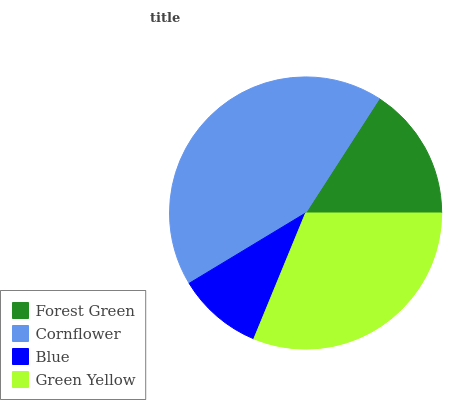Is Blue the minimum?
Answer yes or no. Yes. Is Cornflower the maximum?
Answer yes or no. Yes. Is Cornflower the minimum?
Answer yes or no. No. Is Blue the maximum?
Answer yes or no. No. Is Cornflower greater than Blue?
Answer yes or no. Yes. Is Blue less than Cornflower?
Answer yes or no. Yes. Is Blue greater than Cornflower?
Answer yes or no. No. Is Cornflower less than Blue?
Answer yes or no. No. Is Green Yellow the high median?
Answer yes or no. Yes. Is Forest Green the low median?
Answer yes or no. Yes. Is Blue the high median?
Answer yes or no. No. Is Cornflower the low median?
Answer yes or no. No. 